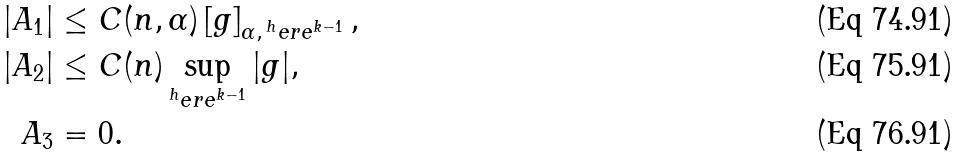<formula> <loc_0><loc_0><loc_500><loc_500>| A _ { 1 } | & \leq C ( n , \alpha ) \left [ g \right ] _ { \alpha , \, ^ { h } e r e ^ { k - 1 } } , \\ | A _ { 2 } | & \leq C ( n ) \sup _ { ^ { h } e r e ^ { k - 1 } } | g | , \\ A _ { 3 } & = 0 .</formula> 